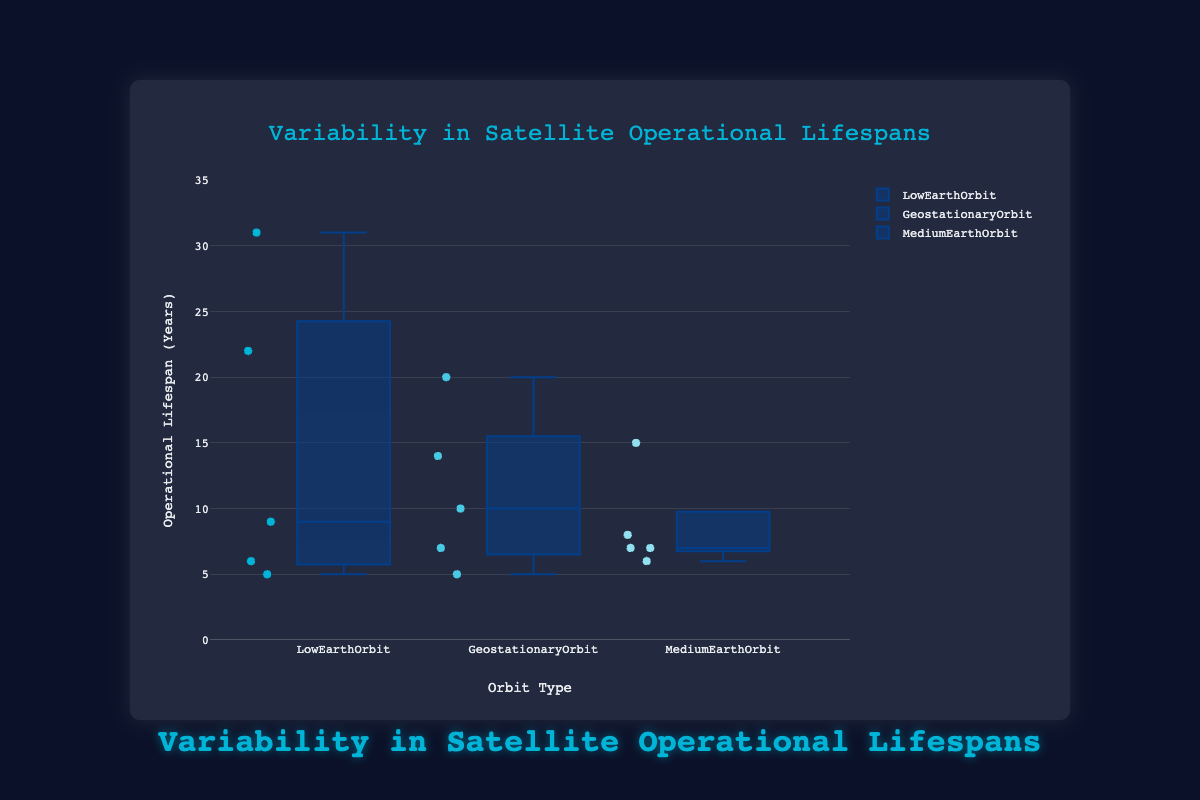What is the title of the plot? The title is typically displayed prominently at the top of the plot. The title of this plot is "Variability in Satellite Operational Lifespans."
Answer: Variability in Satellite Operational Lifespans Which orbit type has the satellite with the longest operational lifespan? By checking the box plot, you can see which satellite has the highest value. The satellite with the longest operational lifespan (31 years) belongs to the Low Earth Orbit, which is the Hubble Space Telescope.
Answer: Low Earth Orbit How many satellites are represented for each orbit type? Each trace represents the satellites for a specific orbit type. By counting the data points (satellites) in each group, you see that there are 5 satellites for Low Earth Orbit, 5 satellites for Geostationary Orbit, and 5 satellites for Medium Earth Orbit.
Answer: 5 each Which orbit type has the widest range of operational lifespan? The range of lifespans can be compared by looking at the span from the minimum to the maximum point in each box plot. Low Earth Orbit spans from 5 to 31 years, which is the widest range (26 years).
Answer: Low Earth Orbit What is the median operational lifespan for Medium Earth Orbit satellites? The median is indicated by the line inside the box of the box plot for Medium Earth Orbit. The median lifespan is 7 years.
Answer: 7 years Are there any outliers in the Geostationary Orbit group? Outliers are typically shown as individual points beyond the typical range of the whiskers in a box plot. There are no outliers shown in the Geostationary Orbit group.
Answer: No Which orbit type has the least variability in satellite operational lifespans? Variability can be assessed by the interquartile range (IQR) or the length of the box. Medium Earth Orbit has the shortest box, indicating the least variability.
Answer: Medium Earth Orbit What is the interquartile range (IQR) for the Low Earth Orbit satellites? The IQR is the difference between the third quartile (Q3) and the first quartile (Q1). For Low Earth Orbit, the box represents this range: from around 6 years (Q1) to around 22 years (Q3), so the IQR is approximately 16 years.
Answer: 16 years Between which values do most of the operational lifespans for Geostationary Orbit satellites fall? Most lifespans fall within the range of the IQR of the box, which is from the first quartile (around 7 years) to the third quartile (around 14 years).
Answer: 7 to 14 years Which satellite in the Medium Earth Orbit has the highest operational lifespan, and what is its lifespan? By looking at the individual points and noting the highest one, the satellite GLONASS-M has the highest lifespan in Medium Earth Orbit with 15 years.
Answer: GLONASS-M, 15 years 